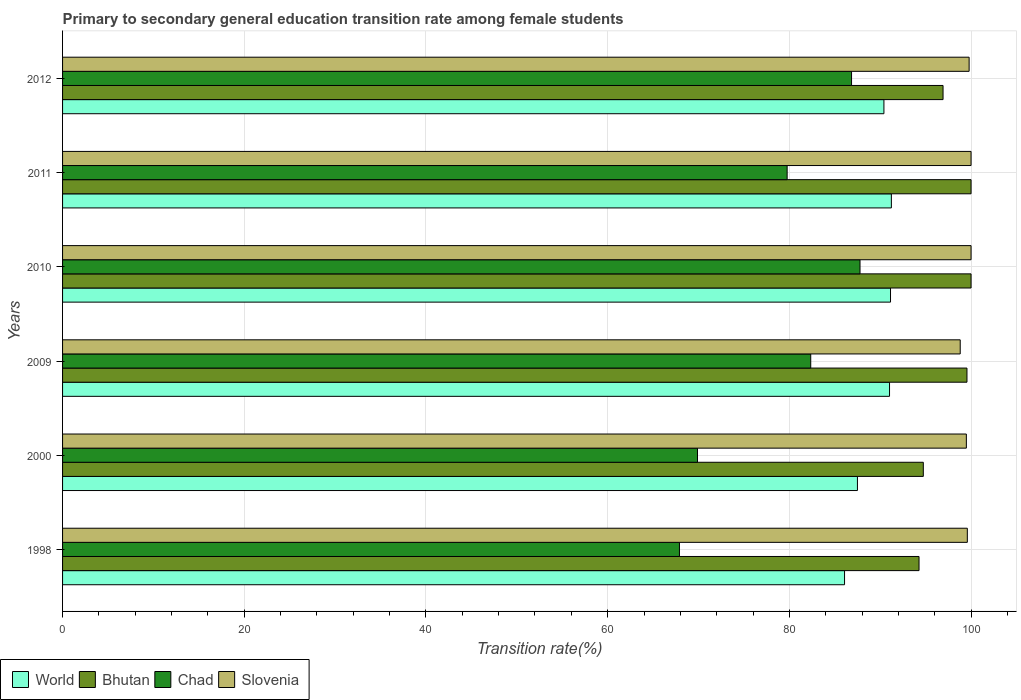How many different coloured bars are there?
Your response must be concise. 4. Are the number of bars per tick equal to the number of legend labels?
Provide a short and direct response. Yes. How many bars are there on the 3rd tick from the top?
Keep it short and to the point. 4. How many bars are there on the 2nd tick from the bottom?
Your answer should be compact. 4. What is the transition rate in Chad in 1998?
Give a very brief answer. 67.9. Across all years, what is the maximum transition rate in World?
Offer a terse response. 91.23. Across all years, what is the minimum transition rate in Chad?
Your answer should be compact. 67.9. In which year was the transition rate in Slovenia maximum?
Your answer should be very brief. 2010. In which year was the transition rate in Chad minimum?
Your answer should be compact. 1998. What is the total transition rate in Chad in the graph?
Ensure brevity in your answer.  474.52. What is the difference between the transition rate in Bhutan in 2000 and that in 2009?
Your answer should be very brief. -4.81. What is the difference between the transition rate in Chad in 2009 and the transition rate in Bhutan in 2011?
Ensure brevity in your answer.  -17.65. What is the average transition rate in Chad per year?
Ensure brevity in your answer.  79.09. In the year 2010, what is the difference between the transition rate in World and transition rate in Slovenia?
Your response must be concise. -8.87. What is the ratio of the transition rate in Slovenia in 2009 to that in 2011?
Your response must be concise. 0.99. Is the transition rate in Chad in 2009 less than that in 2012?
Ensure brevity in your answer.  Yes. What is the difference between the highest and the second highest transition rate in Chad?
Make the answer very short. 0.93. What is the difference between the highest and the lowest transition rate in Slovenia?
Your answer should be compact. 1.19. Is it the case that in every year, the sum of the transition rate in World and transition rate in Slovenia is greater than the sum of transition rate in Chad and transition rate in Bhutan?
Ensure brevity in your answer.  No. What does the 2nd bar from the bottom in 1998 represents?
Your answer should be very brief. Bhutan. Is it the case that in every year, the sum of the transition rate in Bhutan and transition rate in Chad is greater than the transition rate in Slovenia?
Ensure brevity in your answer.  Yes. Are all the bars in the graph horizontal?
Give a very brief answer. Yes. How many years are there in the graph?
Provide a short and direct response. 6. Are the values on the major ticks of X-axis written in scientific E-notation?
Your response must be concise. No. Does the graph contain any zero values?
Provide a succinct answer. No. Where does the legend appear in the graph?
Ensure brevity in your answer.  Bottom left. What is the title of the graph?
Your response must be concise. Primary to secondary general education transition rate among female students. What is the label or title of the X-axis?
Offer a very short reply. Transition rate(%). What is the label or title of the Y-axis?
Offer a very short reply. Years. What is the Transition rate(%) in World in 1998?
Give a very brief answer. 86.07. What is the Transition rate(%) in Bhutan in 1998?
Provide a short and direct response. 94.27. What is the Transition rate(%) of Chad in 1998?
Your answer should be compact. 67.9. What is the Transition rate(%) in Slovenia in 1998?
Your answer should be compact. 99.59. What is the Transition rate(%) of World in 2000?
Keep it short and to the point. 87.49. What is the Transition rate(%) in Bhutan in 2000?
Provide a short and direct response. 94.74. What is the Transition rate(%) in Chad in 2000?
Ensure brevity in your answer.  69.89. What is the Transition rate(%) of Slovenia in 2000?
Provide a short and direct response. 99.48. What is the Transition rate(%) of World in 2009?
Ensure brevity in your answer.  91.02. What is the Transition rate(%) of Bhutan in 2009?
Provide a short and direct response. 99.55. What is the Transition rate(%) in Chad in 2009?
Offer a very short reply. 82.35. What is the Transition rate(%) in Slovenia in 2009?
Ensure brevity in your answer.  98.81. What is the Transition rate(%) of World in 2010?
Your answer should be very brief. 91.13. What is the Transition rate(%) in Chad in 2010?
Provide a succinct answer. 87.78. What is the Transition rate(%) of Slovenia in 2010?
Offer a terse response. 100. What is the Transition rate(%) of World in 2011?
Make the answer very short. 91.23. What is the Transition rate(%) of Bhutan in 2011?
Provide a short and direct response. 100. What is the Transition rate(%) in Chad in 2011?
Offer a terse response. 79.76. What is the Transition rate(%) of Slovenia in 2011?
Offer a very short reply. 100. What is the Transition rate(%) of World in 2012?
Your response must be concise. 90.41. What is the Transition rate(%) in Bhutan in 2012?
Ensure brevity in your answer.  96.92. What is the Transition rate(%) of Chad in 2012?
Ensure brevity in your answer.  86.84. What is the Transition rate(%) of Slovenia in 2012?
Make the answer very short. 99.79. Across all years, what is the maximum Transition rate(%) in World?
Ensure brevity in your answer.  91.23. Across all years, what is the maximum Transition rate(%) in Bhutan?
Offer a very short reply. 100. Across all years, what is the maximum Transition rate(%) of Chad?
Make the answer very short. 87.78. Across all years, what is the minimum Transition rate(%) of World?
Provide a succinct answer. 86.07. Across all years, what is the minimum Transition rate(%) of Bhutan?
Your answer should be compact. 94.27. Across all years, what is the minimum Transition rate(%) in Chad?
Make the answer very short. 67.9. Across all years, what is the minimum Transition rate(%) of Slovenia?
Ensure brevity in your answer.  98.81. What is the total Transition rate(%) in World in the graph?
Your response must be concise. 537.36. What is the total Transition rate(%) in Bhutan in the graph?
Your answer should be very brief. 585.48. What is the total Transition rate(%) of Chad in the graph?
Ensure brevity in your answer.  474.52. What is the total Transition rate(%) of Slovenia in the graph?
Keep it short and to the point. 597.66. What is the difference between the Transition rate(%) of World in 1998 and that in 2000?
Give a very brief answer. -1.42. What is the difference between the Transition rate(%) in Bhutan in 1998 and that in 2000?
Your response must be concise. -0.47. What is the difference between the Transition rate(%) of Chad in 1998 and that in 2000?
Your answer should be very brief. -1.99. What is the difference between the Transition rate(%) of Slovenia in 1998 and that in 2000?
Your answer should be very brief. 0.11. What is the difference between the Transition rate(%) in World in 1998 and that in 2009?
Keep it short and to the point. -4.95. What is the difference between the Transition rate(%) in Bhutan in 1998 and that in 2009?
Offer a terse response. -5.28. What is the difference between the Transition rate(%) of Chad in 1998 and that in 2009?
Make the answer very short. -14.45. What is the difference between the Transition rate(%) of Slovenia in 1998 and that in 2009?
Provide a succinct answer. 0.78. What is the difference between the Transition rate(%) of World in 1998 and that in 2010?
Provide a short and direct response. -5.06. What is the difference between the Transition rate(%) of Bhutan in 1998 and that in 2010?
Your answer should be very brief. -5.73. What is the difference between the Transition rate(%) of Chad in 1998 and that in 2010?
Give a very brief answer. -19.87. What is the difference between the Transition rate(%) of Slovenia in 1998 and that in 2010?
Ensure brevity in your answer.  -0.41. What is the difference between the Transition rate(%) of World in 1998 and that in 2011?
Your answer should be compact. -5.15. What is the difference between the Transition rate(%) in Bhutan in 1998 and that in 2011?
Give a very brief answer. -5.73. What is the difference between the Transition rate(%) of Chad in 1998 and that in 2011?
Your response must be concise. -11.85. What is the difference between the Transition rate(%) of Slovenia in 1998 and that in 2011?
Keep it short and to the point. -0.41. What is the difference between the Transition rate(%) of World in 1998 and that in 2012?
Keep it short and to the point. -4.33. What is the difference between the Transition rate(%) in Bhutan in 1998 and that in 2012?
Make the answer very short. -2.64. What is the difference between the Transition rate(%) in Chad in 1998 and that in 2012?
Make the answer very short. -18.94. What is the difference between the Transition rate(%) in Slovenia in 1998 and that in 2012?
Your answer should be compact. -0.2. What is the difference between the Transition rate(%) of World in 2000 and that in 2009?
Give a very brief answer. -3.53. What is the difference between the Transition rate(%) in Bhutan in 2000 and that in 2009?
Provide a short and direct response. -4.81. What is the difference between the Transition rate(%) of Chad in 2000 and that in 2009?
Your answer should be compact. -12.46. What is the difference between the Transition rate(%) in Slovenia in 2000 and that in 2009?
Make the answer very short. 0.68. What is the difference between the Transition rate(%) of World in 2000 and that in 2010?
Ensure brevity in your answer.  -3.64. What is the difference between the Transition rate(%) in Bhutan in 2000 and that in 2010?
Provide a succinct answer. -5.26. What is the difference between the Transition rate(%) in Chad in 2000 and that in 2010?
Provide a succinct answer. -17.89. What is the difference between the Transition rate(%) of Slovenia in 2000 and that in 2010?
Your answer should be compact. -0.52. What is the difference between the Transition rate(%) of World in 2000 and that in 2011?
Your answer should be very brief. -3.73. What is the difference between the Transition rate(%) of Bhutan in 2000 and that in 2011?
Provide a succinct answer. -5.26. What is the difference between the Transition rate(%) of Chad in 2000 and that in 2011?
Provide a succinct answer. -9.87. What is the difference between the Transition rate(%) of Slovenia in 2000 and that in 2011?
Provide a succinct answer. -0.52. What is the difference between the Transition rate(%) of World in 2000 and that in 2012?
Your answer should be very brief. -2.91. What is the difference between the Transition rate(%) of Bhutan in 2000 and that in 2012?
Offer a very short reply. -2.17. What is the difference between the Transition rate(%) in Chad in 2000 and that in 2012?
Your response must be concise. -16.96. What is the difference between the Transition rate(%) of Slovenia in 2000 and that in 2012?
Provide a short and direct response. -0.3. What is the difference between the Transition rate(%) of World in 2009 and that in 2010?
Offer a terse response. -0.11. What is the difference between the Transition rate(%) of Bhutan in 2009 and that in 2010?
Make the answer very short. -0.45. What is the difference between the Transition rate(%) in Chad in 2009 and that in 2010?
Make the answer very short. -5.42. What is the difference between the Transition rate(%) in Slovenia in 2009 and that in 2010?
Keep it short and to the point. -1.19. What is the difference between the Transition rate(%) of World in 2009 and that in 2011?
Your answer should be compact. -0.2. What is the difference between the Transition rate(%) of Bhutan in 2009 and that in 2011?
Keep it short and to the point. -0.45. What is the difference between the Transition rate(%) of Chad in 2009 and that in 2011?
Make the answer very short. 2.6. What is the difference between the Transition rate(%) in Slovenia in 2009 and that in 2011?
Provide a short and direct response. -1.19. What is the difference between the Transition rate(%) in World in 2009 and that in 2012?
Your answer should be very brief. 0.62. What is the difference between the Transition rate(%) of Bhutan in 2009 and that in 2012?
Your answer should be very brief. 2.63. What is the difference between the Transition rate(%) of Chad in 2009 and that in 2012?
Your response must be concise. -4.49. What is the difference between the Transition rate(%) of Slovenia in 2009 and that in 2012?
Provide a succinct answer. -0.98. What is the difference between the Transition rate(%) in World in 2010 and that in 2011?
Your answer should be compact. -0.09. What is the difference between the Transition rate(%) of Bhutan in 2010 and that in 2011?
Provide a short and direct response. 0. What is the difference between the Transition rate(%) of Chad in 2010 and that in 2011?
Offer a very short reply. 8.02. What is the difference between the Transition rate(%) in World in 2010 and that in 2012?
Your answer should be compact. 0.73. What is the difference between the Transition rate(%) in Bhutan in 2010 and that in 2012?
Your answer should be compact. 3.08. What is the difference between the Transition rate(%) of Chad in 2010 and that in 2012?
Your response must be concise. 0.93. What is the difference between the Transition rate(%) in Slovenia in 2010 and that in 2012?
Make the answer very short. 0.21. What is the difference between the Transition rate(%) of World in 2011 and that in 2012?
Give a very brief answer. 0.82. What is the difference between the Transition rate(%) in Bhutan in 2011 and that in 2012?
Provide a succinct answer. 3.08. What is the difference between the Transition rate(%) in Chad in 2011 and that in 2012?
Ensure brevity in your answer.  -7.09. What is the difference between the Transition rate(%) of Slovenia in 2011 and that in 2012?
Your response must be concise. 0.21. What is the difference between the Transition rate(%) in World in 1998 and the Transition rate(%) in Bhutan in 2000?
Give a very brief answer. -8.67. What is the difference between the Transition rate(%) in World in 1998 and the Transition rate(%) in Chad in 2000?
Your answer should be very brief. 16.19. What is the difference between the Transition rate(%) of World in 1998 and the Transition rate(%) of Slovenia in 2000?
Keep it short and to the point. -13.41. What is the difference between the Transition rate(%) of Bhutan in 1998 and the Transition rate(%) of Chad in 2000?
Offer a terse response. 24.38. What is the difference between the Transition rate(%) in Bhutan in 1998 and the Transition rate(%) in Slovenia in 2000?
Ensure brevity in your answer.  -5.21. What is the difference between the Transition rate(%) of Chad in 1998 and the Transition rate(%) of Slovenia in 2000?
Ensure brevity in your answer.  -31.58. What is the difference between the Transition rate(%) of World in 1998 and the Transition rate(%) of Bhutan in 2009?
Provide a succinct answer. -13.47. What is the difference between the Transition rate(%) in World in 1998 and the Transition rate(%) in Chad in 2009?
Offer a very short reply. 3.72. What is the difference between the Transition rate(%) in World in 1998 and the Transition rate(%) in Slovenia in 2009?
Offer a very short reply. -12.73. What is the difference between the Transition rate(%) of Bhutan in 1998 and the Transition rate(%) of Chad in 2009?
Your answer should be very brief. 11.92. What is the difference between the Transition rate(%) of Bhutan in 1998 and the Transition rate(%) of Slovenia in 2009?
Your answer should be very brief. -4.53. What is the difference between the Transition rate(%) of Chad in 1998 and the Transition rate(%) of Slovenia in 2009?
Your answer should be very brief. -30.9. What is the difference between the Transition rate(%) in World in 1998 and the Transition rate(%) in Bhutan in 2010?
Offer a very short reply. -13.93. What is the difference between the Transition rate(%) of World in 1998 and the Transition rate(%) of Chad in 2010?
Ensure brevity in your answer.  -1.7. What is the difference between the Transition rate(%) in World in 1998 and the Transition rate(%) in Slovenia in 2010?
Keep it short and to the point. -13.93. What is the difference between the Transition rate(%) in Bhutan in 1998 and the Transition rate(%) in Chad in 2010?
Give a very brief answer. 6.5. What is the difference between the Transition rate(%) in Bhutan in 1998 and the Transition rate(%) in Slovenia in 2010?
Give a very brief answer. -5.73. What is the difference between the Transition rate(%) of Chad in 1998 and the Transition rate(%) of Slovenia in 2010?
Ensure brevity in your answer.  -32.1. What is the difference between the Transition rate(%) in World in 1998 and the Transition rate(%) in Bhutan in 2011?
Give a very brief answer. -13.93. What is the difference between the Transition rate(%) in World in 1998 and the Transition rate(%) in Chad in 2011?
Provide a short and direct response. 6.32. What is the difference between the Transition rate(%) in World in 1998 and the Transition rate(%) in Slovenia in 2011?
Your answer should be compact. -13.93. What is the difference between the Transition rate(%) of Bhutan in 1998 and the Transition rate(%) of Chad in 2011?
Your answer should be very brief. 14.52. What is the difference between the Transition rate(%) of Bhutan in 1998 and the Transition rate(%) of Slovenia in 2011?
Offer a terse response. -5.73. What is the difference between the Transition rate(%) in Chad in 1998 and the Transition rate(%) in Slovenia in 2011?
Provide a short and direct response. -32.1. What is the difference between the Transition rate(%) in World in 1998 and the Transition rate(%) in Bhutan in 2012?
Your answer should be very brief. -10.84. What is the difference between the Transition rate(%) of World in 1998 and the Transition rate(%) of Chad in 2012?
Make the answer very short. -0.77. What is the difference between the Transition rate(%) of World in 1998 and the Transition rate(%) of Slovenia in 2012?
Offer a very short reply. -13.71. What is the difference between the Transition rate(%) in Bhutan in 1998 and the Transition rate(%) in Chad in 2012?
Provide a succinct answer. 7.43. What is the difference between the Transition rate(%) in Bhutan in 1998 and the Transition rate(%) in Slovenia in 2012?
Your answer should be very brief. -5.51. What is the difference between the Transition rate(%) in Chad in 1998 and the Transition rate(%) in Slovenia in 2012?
Your response must be concise. -31.88. What is the difference between the Transition rate(%) of World in 2000 and the Transition rate(%) of Bhutan in 2009?
Provide a succinct answer. -12.06. What is the difference between the Transition rate(%) of World in 2000 and the Transition rate(%) of Chad in 2009?
Your answer should be very brief. 5.14. What is the difference between the Transition rate(%) of World in 2000 and the Transition rate(%) of Slovenia in 2009?
Give a very brief answer. -11.31. What is the difference between the Transition rate(%) in Bhutan in 2000 and the Transition rate(%) in Chad in 2009?
Give a very brief answer. 12.39. What is the difference between the Transition rate(%) in Bhutan in 2000 and the Transition rate(%) in Slovenia in 2009?
Offer a terse response. -4.06. What is the difference between the Transition rate(%) of Chad in 2000 and the Transition rate(%) of Slovenia in 2009?
Give a very brief answer. -28.92. What is the difference between the Transition rate(%) in World in 2000 and the Transition rate(%) in Bhutan in 2010?
Ensure brevity in your answer.  -12.51. What is the difference between the Transition rate(%) in World in 2000 and the Transition rate(%) in Chad in 2010?
Give a very brief answer. -0.28. What is the difference between the Transition rate(%) in World in 2000 and the Transition rate(%) in Slovenia in 2010?
Ensure brevity in your answer.  -12.51. What is the difference between the Transition rate(%) of Bhutan in 2000 and the Transition rate(%) of Chad in 2010?
Offer a terse response. 6.97. What is the difference between the Transition rate(%) of Bhutan in 2000 and the Transition rate(%) of Slovenia in 2010?
Your answer should be very brief. -5.26. What is the difference between the Transition rate(%) of Chad in 2000 and the Transition rate(%) of Slovenia in 2010?
Make the answer very short. -30.11. What is the difference between the Transition rate(%) in World in 2000 and the Transition rate(%) in Bhutan in 2011?
Offer a very short reply. -12.51. What is the difference between the Transition rate(%) of World in 2000 and the Transition rate(%) of Chad in 2011?
Make the answer very short. 7.74. What is the difference between the Transition rate(%) of World in 2000 and the Transition rate(%) of Slovenia in 2011?
Offer a very short reply. -12.51. What is the difference between the Transition rate(%) of Bhutan in 2000 and the Transition rate(%) of Chad in 2011?
Provide a short and direct response. 14.99. What is the difference between the Transition rate(%) in Bhutan in 2000 and the Transition rate(%) in Slovenia in 2011?
Give a very brief answer. -5.26. What is the difference between the Transition rate(%) in Chad in 2000 and the Transition rate(%) in Slovenia in 2011?
Offer a terse response. -30.11. What is the difference between the Transition rate(%) of World in 2000 and the Transition rate(%) of Bhutan in 2012?
Your response must be concise. -9.42. What is the difference between the Transition rate(%) in World in 2000 and the Transition rate(%) in Chad in 2012?
Your answer should be compact. 0.65. What is the difference between the Transition rate(%) in World in 2000 and the Transition rate(%) in Slovenia in 2012?
Offer a terse response. -12.29. What is the difference between the Transition rate(%) in Bhutan in 2000 and the Transition rate(%) in Chad in 2012?
Ensure brevity in your answer.  7.9. What is the difference between the Transition rate(%) in Bhutan in 2000 and the Transition rate(%) in Slovenia in 2012?
Your answer should be compact. -5.04. What is the difference between the Transition rate(%) of Chad in 2000 and the Transition rate(%) of Slovenia in 2012?
Offer a very short reply. -29.9. What is the difference between the Transition rate(%) in World in 2009 and the Transition rate(%) in Bhutan in 2010?
Offer a very short reply. -8.98. What is the difference between the Transition rate(%) in World in 2009 and the Transition rate(%) in Chad in 2010?
Keep it short and to the point. 3.25. What is the difference between the Transition rate(%) of World in 2009 and the Transition rate(%) of Slovenia in 2010?
Your answer should be very brief. -8.98. What is the difference between the Transition rate(%) of Bhutan in 2009 and the Transition rate(%) of Chad in 2010?
Provide a succinct answer. 11.77. What is the difference between the Transition rate(%) of Bhutan in 2009 and the Transition rate(%) of Slovenia in 2010?
Provide a short and direct response. -0.45. What is the difference between the Transition rate(%) in Chad in 2009 and the Transition rate(%) in Slovenia in 2010?
Offer a very short reply. -17.65. What is the difference between the Transition rate(%) in World in 2009 and the Transition rate(%) in Bhutan in 2011?
Ensure brevity in your answer.  -8.98. What is the difference between the Transition rate(%) in World in 2009 and the Transition rate(%) in Chad in 2011?
Keep it short and to the point. 11.27. What is the difference between the Transition rate(%) in World in 2009 and the Transition rate(%) in Slovenia in 2011?
Your answer should be very brief. -8.98. What is the difference between the Transition rate(%) in Bhutan in 2009 and the Transition rate(%) in Chad in 2011?
Provide a short and direct response. 19.79. What is the difference between the Transition rate(%) of Bhutan in 2009 and the Transition rate(%) of Slovenia in 2011?
Your answer should be compact. -0.45. What is the difference between the Transition rate(%) in Chad in 2009 and the Transition rate(%) in Slovenia in 2011?
Offer a terse response. -17.65. What is the difference between the Transition rate(%) of World in 2009 and the Transition rate(%) of Bhutan in 2012?
Your answer should be very brief. -5.89. What is the difference between the Transition rate(%) in World in 2009 and the Transition rate(%) in Chad in 2012?
Provide a succinct answer. 4.18. What is the difference between the Transition rate(%) of World in 2009 and the Transition rate(%) of Slovenia in 2012?
Your answer should be compact. -8.76. What is the difference between the Transition rate(%) in Bhutan in 2009 and the Transition rate(%) in Chad in 2012?
Offer a very short reply. 12.7. What is the difference between the Transition rate(%) in Bhutan in 2009 and the Transition rate(%) in Slovenia in 2012?
Offer a terse response. -0.24. What is the difference between the Transition rate(%) of Chad in 2009 and the Transition rate(%) of Slovenia in 2012?
Give a very brief answer. -17.43. What is the difference between the Transition rate(%) of World in 2010 and the Transition rate(%) of Bhutan in 2011?
Offer a terse response. -8.87. What is the difference between the Transition rate(%) of World in 2010 and the Transition rate(%) of Chad in 2011?
Your answer should be compact. 11.38. What is the difference between the Transition rate(%) in World in 2010 and the Transition rate(%) in Slovenia in 2011?
Offer a very short reply. -8.87. What is the difference between the Transition rate(%) in Bhutan in 2010 and the Transition rate(%) in Chad in 2011?
Ensure brevity in your answer.  20.24. What is the difference between the Transition rate(%) of Chad in 2010 and the Transition rate(%) of Slovenia in 2011?
Provide a short and direct response. -12.22. What is the difference between the Transition rate(%) in World in 2010 and the Transition rate(%) in Bhutan in 2012?
Give a very brief answer. -5.78. What is the difference between the Transition rate(%) of World in 2010 and the Transition rate(%) of Chad in 2012?
Offer a terse response. 4.29. What is the difference between the Transition rate(%) of World in 2010 and the Transition rate(%) of Slovenia in 2012?
Your response must be concise. -8.65. What is the difference between the Transition rate(%) of Bhutan in 2010 and the Transition rate(%) of Chad in 2012?
Provide a succinct answer. 13.16. What is the difference between the Transition rate(%) of Bhutan in 2010 and the Transition rate(%) of Slovenia in 2012?
Your answer should be very brief. 0.21. What is the difference between the Transition rate(%) of Chad in 2010 and the Transition rate(%) of Slovenia in 2012?
Offer a terse response. -12.01. What is the difference between the Transition rate(%) in World in 2011 and the Transition rate(%) in Bhutan in 2012?
Ensure brevity in your answer.  -5.69. What is the difference between the Transition rate(%) of World in 2011 and the Transition rate(%) of Chad in 2012?
Offer a terse response. 4.38. What is the difference between the Transition rate(%) in World in 2011 and the Transition rate(%) in Slovenia in 2012?
Keep it short and to the point. -8.56. What is the difference between the Transition rate(%) of Bhutan in 2011 and the Transition rate(%) of Chad in 2012?
Ensure brevity in your answer.  13.16. What is the difference between the Transition rate(%) of Bhutan in 2011 and the Transition rate(%) of Slovenia in 2012?
Your answer should be compact. 0.21. What is the difference between the Transition rate(%) of Chad in 2011 and the Transition rate(%) of Slovenia in 2012?
Your answer should be compact. -20.03. What is the average Transition rate(%) of World per year?
Provide a short and direct response. 89.56. What is the average Transition rate(%) in Bhutan per year?
Offer a terse response. 97.58. What is the average Transition rate(%) of Chad per year?
Your response must be concise. 79.09. What is the average Transition rate(%) of Slovenia per year?
Provide a short and direct response. 99.61. In the year 1998, what is the difference between the Transition rate(%) of World and Transition rate(%) of Bhutan?
Give a very brief answer. -8.2. In the year 1998, what is the difference between the Transition rate(%) of World and Transition rate(%) of Chad?
Give a very brief answer. 18.17. In the year 1998, what is the difference between the Transition rate(%) of World and Transition rate(%) of Slovenia?
Ensure brevity in your answer.  -13.51. In the year 1998, what is the difference between the Transition rate(%) of Bhutan and Transition rate(%) of Chad?
Ensure brevity in your answer.  26.37. In the year 1998, what is the difference between the Transition rate(%) in Bhutan and Transition rate(%) in Slovenia?
Offer a terse response. -5.32. In the year 1998, what is the difference between the Transition rate(%) in Chad and Transition rate(%) in Slovenia?
Provide a short and direct response. -31.69. In the year 2000, what is the difference between the Transition rate(%) of World and Transition rate(%) of Bhutan?
Offer a terse response. -7.25. In the year 2000, what is the difference between the Transition rate(%) in World and Transition rate(%) in Chad?
Your response must be concise. 17.61. In the year 2000, what is the difference between the Transition rate(%) of World and Transition rate(%) of Slovenia?
Give a very brief answer. -11.99. In the year 2000, what is the difference between the Transition rate(%) of Bhutan and Transition rate(%) of Chad?
Give a very brief answer. 24.86. In the year 2000, what is the difference between the Transition rate(%) in Bhutan and Transition rate(%) in Slovenia?
Your answer should be compact. -4.74. In the year 2000, what is the difference between the Transition rate(%) in Chad and Transition rate(%) in Slovenia?
Your answer should be compact. -29.59. In the year 2009, what is the difference between the Transition rate(%) of World and Transition rate(%) of Bhutan?
Provide a succinct answer. -8.52. In the year 2009, what is the difference between the Transition rate(%) of World and Transition rate(%) of Chad?
Offer a terse response. 8.67. In the year 2009, what is the difference between the Transition rate(%) in World and Transition rate(%) in Slovenia?
Provide a short and direct response. -7.78. In the year 2009, what is the difference between the Transition rate(%) in Bhutan and Transition rate(%) in Chad?
Provide a short and direct response. 17.2. In the year 2009, what is the difference between the Transition rate(%) of Bhutan and Transition rate(%) of Slovenia?
Your answer should be compact. 0.74. In the year 2009, what is the difference between the Transition rate(%) in Chad and Transition rate(%) in Slovenia?
Provide a succinct answer. -16.45. In the year 2010, what is the difference between the Transition rate(%) of World and Transition rate(%) of Bhutan?
Provide a short and direct response. -8.87. In the year 2010, what is the difference between the Transition rate(%) of World and Transition rate(%) of Chad?
Provide a succinct answer. 3.36. In the year 2010, what is the difference between the Transition rate(%) of World and Transition rate(%) of Slovenia?
Your answer should be compact. -8.87. In the year 2010, what is the difference between the Transition rate(%) of Bhutan and Transition rate(%) of Chad?
Provide a short and direct response. 12.22. In the year 2010, what is the difference between the Transition rate(%) of Chad and Transition rate(%) of Slovenia?
Provide a succinct answer. -12.22. In the year 2011, what is the difference between the Transition rate(%) in World and Transition rate(%) in Bhutan?
Your response must be concise. -8.77. In the year 2011, what is the difference between the Transition rate(%) of World and Transition rate(%) of Chad?
Ensure brevity in your answer.  11.47. In the year 2011, what is the difference between the Transition rate(%) in World and Transition rate(%) in Slovenia?
Keep it short and to the point. -8.77. In the year 2011, what is the difference between the Transition rate(%) of Bhutan and Transition rate(%) of Chad?
Make the answer very short. 20.24. In the year 2011, what is the difference between the Transition rate(%) of Chad and Transition rate(%) of Slovenia?
Your answer should be very brief. -20.24. In the year 2012, what is the difference between the Transition rate(%) in World and Transition rate(%) in Bhutan?
Your answer should be very brief. -6.51. In the year 2012, what is the difference between the Transition rate(%) in World and Transition rate(%) in Chad?
Offer a very short reply. 3.56. In the year 2012, what is the difference between the Transition rate(%) of World and Transition rate(%) of Slovenia?
Provide a short and direct response. -9.38. In the year 2012, what is the difference between the Transition rate(%) of Bhutan and Transition rate(%) of Chad?
Make the answer very short. 10.07. In the year 2012, what is the difference between the Transition rate(%) of Bhutan and Transition rate(%) of Slovenia?
Your response must be concise. -2.87. In the year 2012, what is the difference between the Transition rate(%) in Chad and Transition rate(%) in Slovenia?
Offer a very short reply. -12.94. What is the ratio of the Transition rate(%) of World in 1998 to that in 2000?
Offer a terse response. 0.98. What is the ratio of the Transition rate(%) of Chad in 1998 to that in 2000?
Provide a succinct answer. 0.97. What is the ratio of the Transition rate(%) in Slovenia in 1998 to that in 2000?
Your response must be concise. 1. What is the ratio of the Transition rate(%) in World in 1998 to that in 2009?
Offer a terse response. 0.95. What is the ratio of the Transition rate(%) in Bhutan in 1998 to that in 2009?
Give a very brief answer. 0.95. What is the ratio of the Transition rate(%) in Chad in 1998 to that in 2009?
Offer a very short reply. 0.82. What is the ratio of the Transition rate(%) in Slovenia in 1998 to that in 2009?
Provide a short and direct response. 1.01. What is the ratio of the Transition rate(%) in World in 1998 to that in 2010?
Your response must be concise. 0.94. What is the ratio of the Transition rate(%) in Bhutan in 1998 to that in 2010?
Make the answer very short. 0.94. What is the ratio of the Transition rate(%) of Chad in 1998 to that in 2010?
Make the answer very short. 0.77. What is the ratio of the Transition rate(%) in Slovenia in 1998 to that in 2010?
Your response must be concise. 1. What is the ratio of the Transition rate(%) of World in 1998 to that in 2011?
Provide a succinct answer. 0.94. What is the ratio of the Transition rate(%) in Bhutan in 1998 to that in 2011?
Offer a very short reply. 0.94. What is the ratio of the Transition rate(%) of Chad in 1998 to that in 2011?
Your response must be concise. 0.85. What is the ratio of the Transition rate(%) of World in 1998 to that in 2012?
Make the answer very short. 0.95. What is the ratio of the Transition rate(%) in Bhutan in 1998 to that in 2012?
Provide a succinct answer. 0.97. What is the ratio of the Transition rate(%) in Chad in 1998 to that in 2012?
Offer a terse response. 0.78. What is the ratio of the Transition rate(%) of Slovenia in 1998 to that in 2012?
Offer a terse response. 1. What is the ratio of the Transition rate(%) in World in 2000 to that in 2009?
Your response must be concise. 0.96. What is the ratio of the Transition rate(%) in Bhutan in 2000 to that in 2009?
Make the answer very short. 0.95. What is the ratio of the Transition rate(%) in Chad in 2000 to that in 2009?
Make the answer very short. 0.85. What is the ratio of the Transition rate(%) in Slovenia in 2000 to that in 2009?
Give a very brief answer. 1.01. What is the ratio of the Transition rate(%) in World in 2000 to that in 2010?
Provide a short and direct response. 0.96. What is the ratio of the Transition rate(%) in Bhutan in 2000 to that in 2010?
Ensure brevity in your answer.  0.95. What is the ratio of the Transition rate(%) of Chad in 2000 to that in 2010?
Your answer should be very brief. 0.8. What is the ratio of the Transition rate(%) of World in 2000 to that in 2011?
Give a very brief answer. 0.96. What is the ratio of the Transition rate(%) in Chad in 2000 to that in 2011?
Your answer should be very brief. 0.88. What is the ratio of the Transition rate(%) in World in 2000 to that in 2012?
Offer a very short reply. 0.97. What is the ratio of the Transition rate(%) in Bhutan in 2000 to that in 2012?
Your response must be concise. 0.98. What is the ratio of the Transition rate(%) in Chad in 2000 to that in 2012?
Ensure brevity in your answer.  0.8. What is the ratio of the Transition rate(%) of Chad in 2009 to that in 2010?
Ensure brevity in your answer.  0.94. What is the ratio of the Transition rate(%) in Chad in 2009 to that in 2011?
Provide a short and direct response. 1.03. What is the ratio of the Transition rate(%) in Slovenia in 2009 to that in 2011?
Offer a terse response. 0.99. What is the ratio of the Transition rate(%) in World in 2009 to that in 2012?
Provide a short and direct response. 1.01. What is the ratio of the Transition rate(%) in Bhutan in 2009 to that in 2012?
Make the answer very short. 1.03. What is the ratio of the Transition rate(%) in Chad in 2009 to that in 2012?
Make the answer very short. 0.95. What is the ratio of the Transition rate(%) in Slovenia in 2009 to that in 2012?
Ensure brevity in your answer.  0.99. What is the ratio of the Transition rate(%) of World in 2010 to that in 2011?
Make the answer very short. 1. What is the ratio of the Transition rate(%) in Chad in 2010 to that in 2011?
Offer a terse response. 1.1. What is the ratio of the Transition rate(%) of Bhutan in 2010 to that in 2012?
Your answer should be very brief. 1.03. What is the ratio of the Transition rate(%) of Chad in 2010 to that in 2012?
Offer a terse response. 1.01. What is the ratio of the Transition rate(%) in Slovenia in 2010 to that in 2012?
Your response must be concise. 1. What is the ratio of the Transition rate(%) in World in 2011 to that in 2012?
Keep it short and to the point. 1.01. What is the ratio of the Transition rate(%) in Bhutan in 2011 to that in 2012?
Keep it short and to the point. 1.03. What is the ratio of the Transition rate(%) of Chad in 2011 to that in 2012?
Provide a short and direct response. 0.92. What is the ratio of the Transition rate(%) of Slovenia in 2011 to that in 2012?
Keep it short and to the point. 1. What is the difference between the highest and the second highest Transition rate(%) in World?
Your answer should be very brief. 0.09. What is the difference between the highest and the second highest Transition rate(%) of Bhutan?
Keep it short and to the point. 0. What is the difference between the highest and the second highest Transition rate(%) of Chad?
Your answer should be very brief. 0.93. What is the difference between the highest and the lowest Transition rate(%) in World?
Offer a terse response. 5.15. What is the difference between the highest and the lowest Transition rate(%) in Bhutan?
Your answer should be compact. 5.73. What is the difference between the highest and the lowest Transition rate(%) of Chad?
Your answer should be compact. 19.87. What is the difference between the highest and the lowest Transition rate(%) in Slovenia?
Your response must be concise. 1.19. 